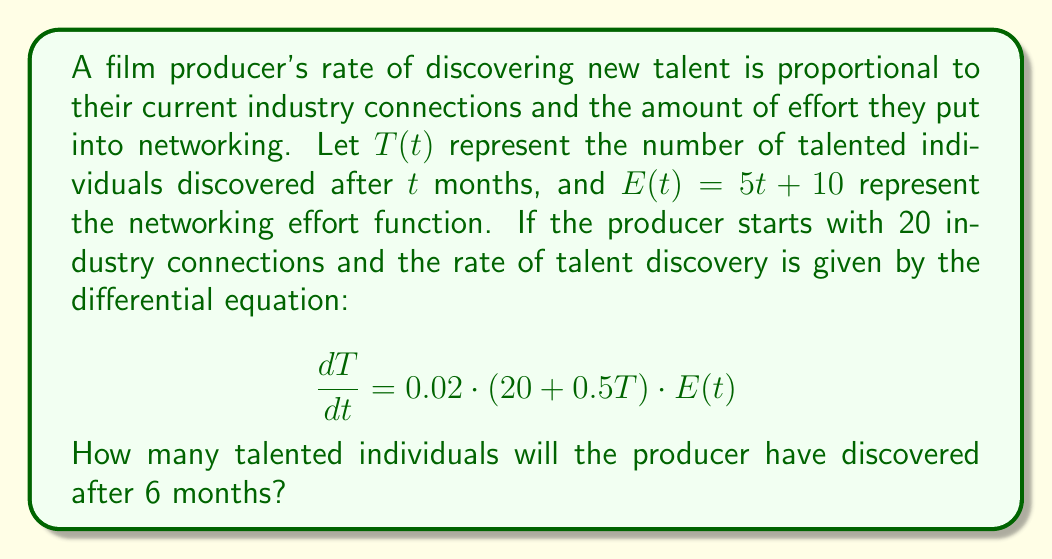What is the answer to this math problem? To solve this problem, we need to use the given first-order differential equation and integrate it over the specified time period. Let's break it down step by step:

1. We start with the differential equation:
   $$\frac{dT}{dt} = 0.02 \cdot (20 + 0.5T) \cdot E(t)$$

2. Substitute $E(t) = 5t + 10$:
   $$\frac{dT}{dt} = 0.02 \cdot (20 + 0.5T) \cdot (5t + 10)$$

3. Expand the equation:
   $$\frac{dT}{dt} = 0.02 \cdot (100t + 200 + 2.5Tt + 5T)$$
   $$\frac{dT}{dt} = 2t + 4 + 0.05Tt + 0.1T$$

4. This is a non-linear differential equation. We can solve it using separation of variables:
   $$\frac{dT}{2t + 4 + 0.05Tt + 0.1T} = dt$$

5. Integrate both sides from $t=0$ to $t=6$:
   $$\int_0^6 \frac{dT}{2t + 4 + 0.05Tt + 0.1T} = \int_0^6 dt$$

6. The left-hand side integral is complex and doesn't have a straightforward analytical solution. In practice, we would use numerical methods to solve this equation.

7. Using a numerical solver (e.g., Runge-Kutta method), we can approximate the solution for $T(6)$.

8. After numerical integration, we find that $T(6) \approx 72.3$.

9. Since we're dealing with whole numbers of talented individuals, we round down to the nearest integer.
Answer: The film producer will have discovered approximately 72 talented individuals after 6 months. 